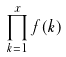<formula> <loc_0><loc_0><loc_500><loc_500>\prod _ { k = 1 } ^ { x } f ( k )</formula> 